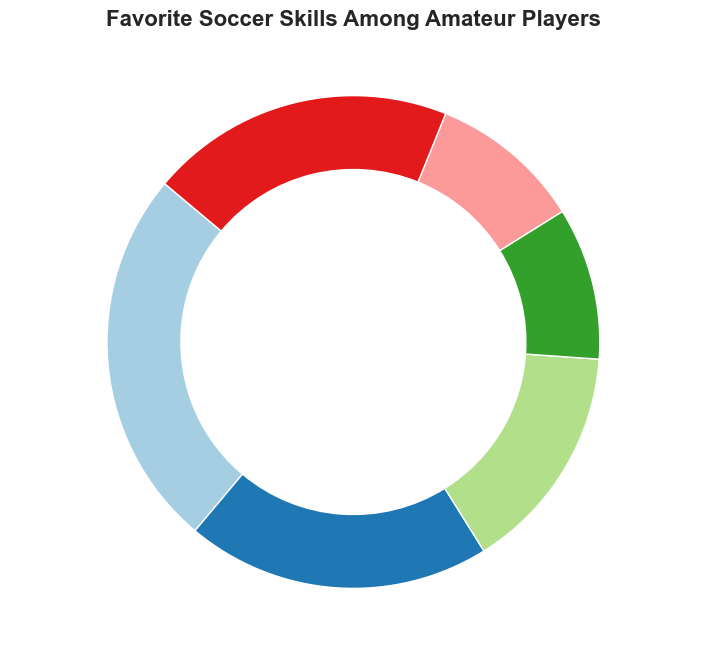What's the most preferred soccer skill among amateur players? To determine the most preferred soccer skill, identify the category with the highest percentage. According to the chart, Dribbling has the highest preference at 25%.
Answer: Dribbling Which two skills are equally preferred and what is their combined percentage? Identify categories with the same percentage. The percentages for Defending and Goalkeeping are both 10%. Their combined percentage is 10% + 10% = 20%.
Answer: Defending and Goalkeeping, 20% How much higher is the percentage of players who prefer Dribbling compared to Passing? Subtract the percentage of Passing from Dribbling. Dribbling is 25%, and Passing is 15%. So, 25% - 15% = 10%.
Answer: 10% Which skill is preferred more: Shooting or Passing? Compare the percentages of Shooting and Passing. Shooting has 20%, while Passing has 15%. Therefore, Shooting is preferred more.
Answer: Shooting What is the combined percentage of the least preferred skills? Identify the categories with the smallest percentages: Defending and Goalkeeping, both 10%. Their combined percentage is 10% + 10% = 20%.
Answer: 20% What percentage of players prefer skills other than the main five listed? The category 'Other' accounts for players who prefer skills not listed as the main five. The percentage is 20%.
Answer: 20% Which skill has the closest percentage to the overall percentage of players who prefer 'Other' skills? Identify the skill whose percentage is closest to the 'Other' skills percentage of 20%. Shooting also has a percentage of 20%, which is closest.
Answer: Shooting Arrange the skills from most preferred to least preferred. List the skills based on their percentages from highest to lowest: Dribbling (25%), Shooting (20%), Passing (15%), Defending (10%), Goalkeeping (10%), Other (20%).
Answer: Dribbling, Shooting, Other, Passing, Defending, Goalkeeping What is the average percentage of the top three preferred skills? Sum the percentages of the top three skills: Dribbling (25%), Shooting (20%), and Other (20%). Calculate the average: (25% + 20% + 20%)/3 = 21.67%.
Answer: 21.67% Which category is represented by the smallest segment on the pie chart? Identify the category with the lowest percentage. Defending and Goalkeeping both have the smallest segments at 10%.
Answer: Defending and Goalkeeping 